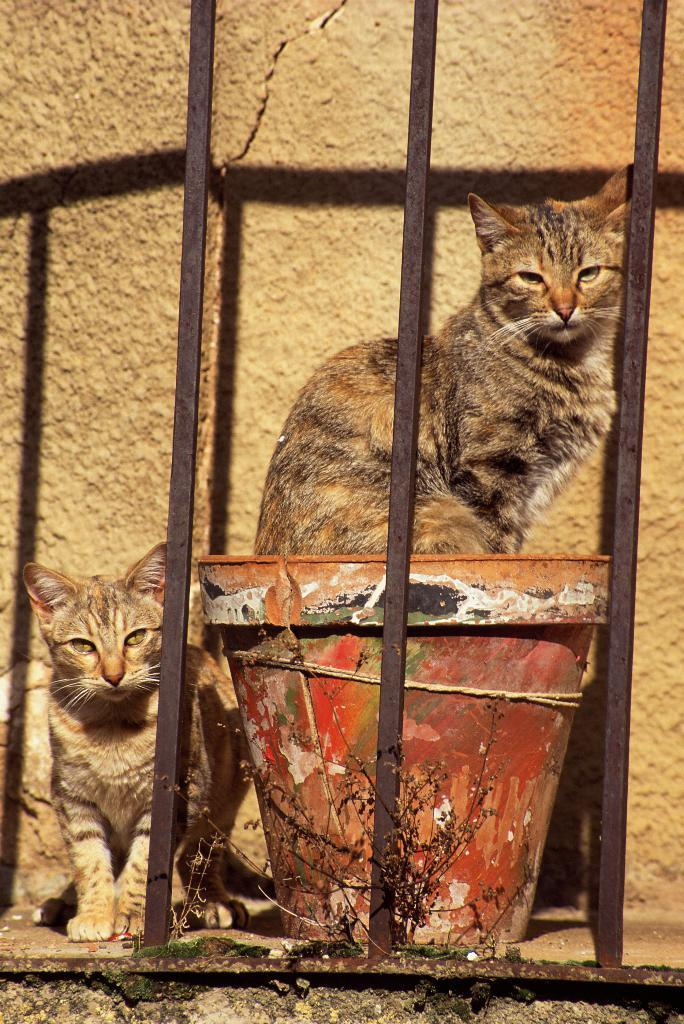What can be seen in the foreground of the image? There is a railing in the foreground of the image. What animals are present in the image? There are two cats in the image, one on a pot and another beside the pot. What is the background of the image? There is a wall in the background of the image. What is the cat's favorite hobby in the image? There is no information about the cat's hobbies in the image. What country is the cat from in the image? The image does not provide information about the cat's country of origin. 